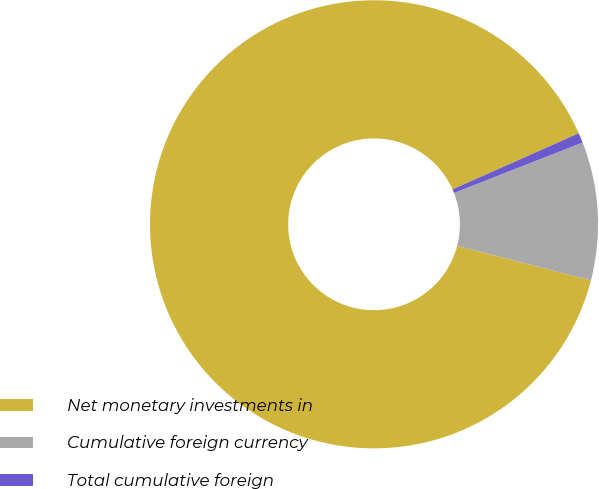<chart> <loc_0><loc_0><loc_500><loc_500><pie_chart><fcel>Net monetary investments in<fcel>Cumulative foreign currency<fcel>Total cumulative foreign<nl><fcel>89.32%<fcel>9.98%<fcel>0.71%<nl></chart> 